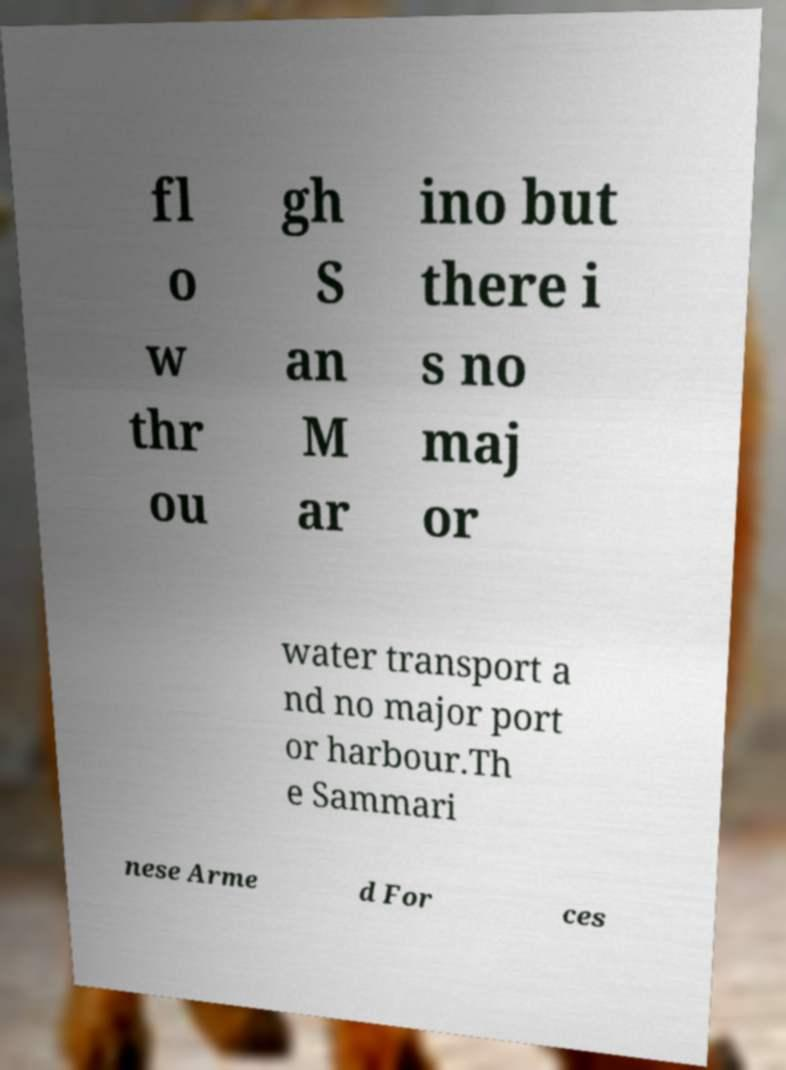Could you extract and type out the text from this image? fl o w thr ou gh S an M ar ino but there i s no maj or water transport a nd no major port or harbour.Th e Sammari nese Arme d For ces 